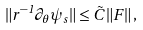Convert formula to latex. <formula><loc_0><loc_0><loc_500><loc_500>\| r ^ { - 1 } \partial _ { \theta } \psi _ { s } \| \leq \tilde { C } \, \| F \| \, ,</formula> 